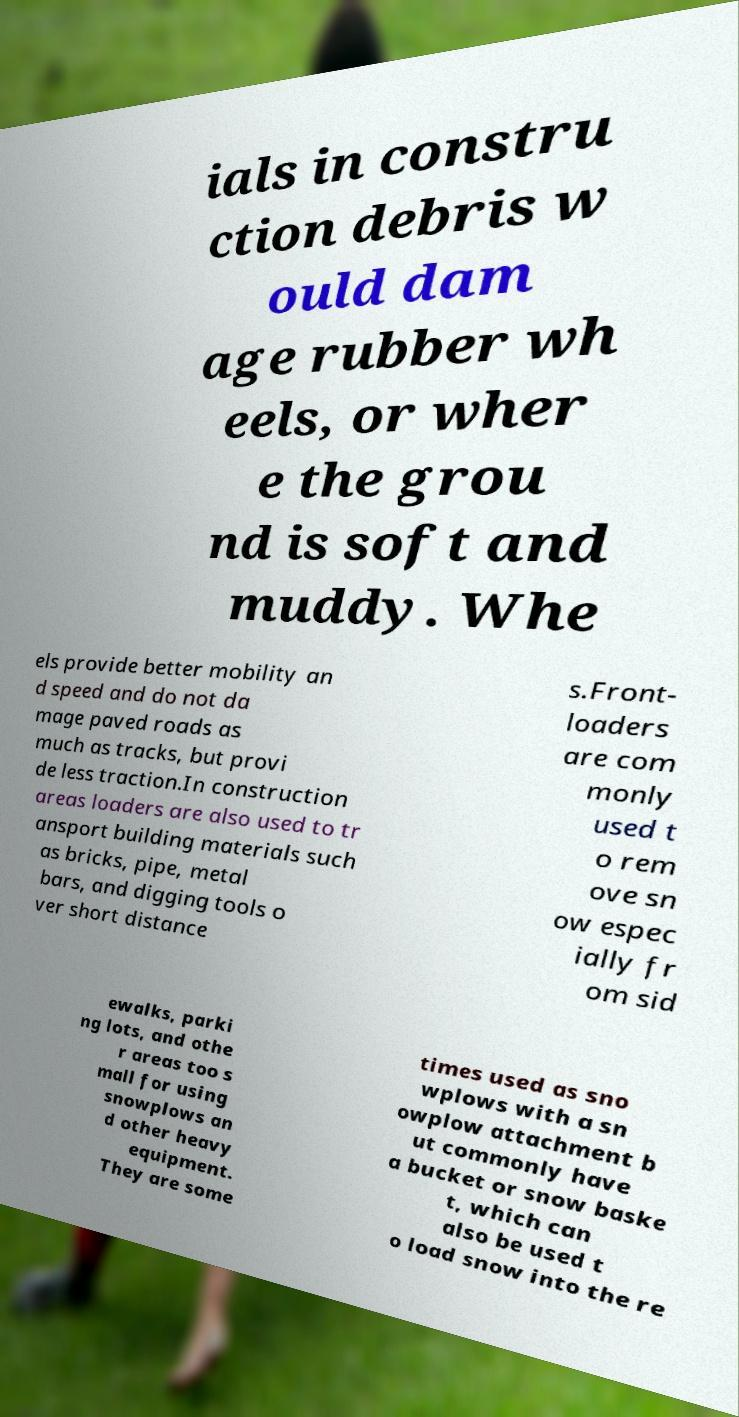Could you extract and type out the text from this image? ials in constru ction debris w ould dam age rubber wh eels, or wher e the grou nd is soft and muddy. Whe els provide better mobility an d speed and do not da mage paved roads as much as tracks, but provi de less traction.In construction areas loaders are also used to tr ansport building materials such as bricks, pipe, metal bars, and digging tools o ver short distance s.Front- loaders are com monly used t o rem ove sn ow espec ially fr om sid ewalks, parki ng lots, and othe r areas too s mall for using snowplows an d other heavy equipment. They are some times used as sno wplows with a sn owplow attachment b ut commonly have a bucket or snow baske t, which can also be used t o load snow into the re 